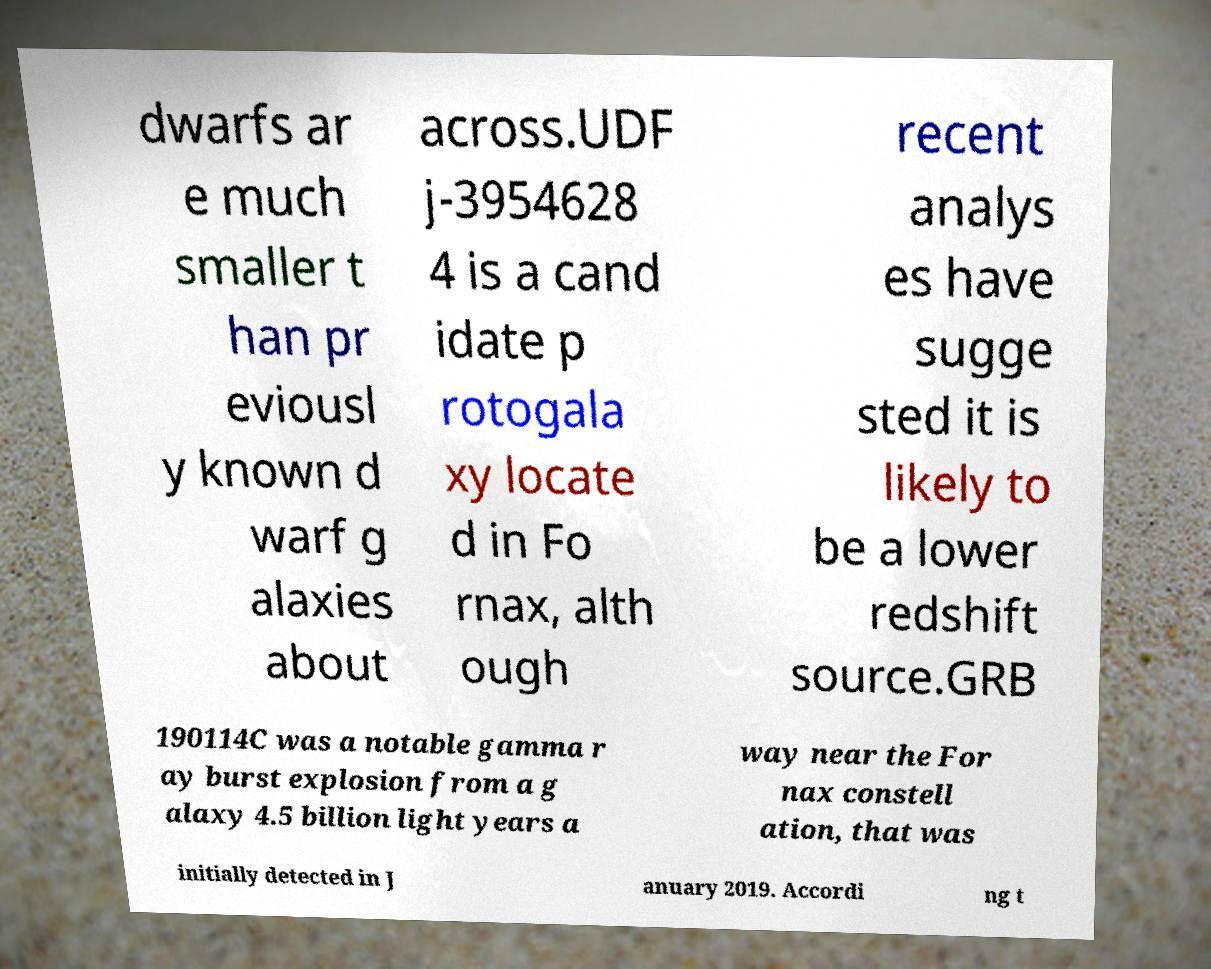There's text embedded in this image that I need extracted. Can you transcribe it verbatim? dwarfs ar e much smaller t han pr eviousl y known d warf g alaxies about across.UDF j-3954628 4 is a cand idate p rotogala xy locate d in Fo rnax, alth ough recent analys es have sugge sted it is likely to be a lower redshift source.GRB 190114C was a notable gamma r ay burst explosion from a g alaxy 4.5 billion light years a way near the For nax constell ation, that was initially detected in J anuary 2019. Accordi ng t 